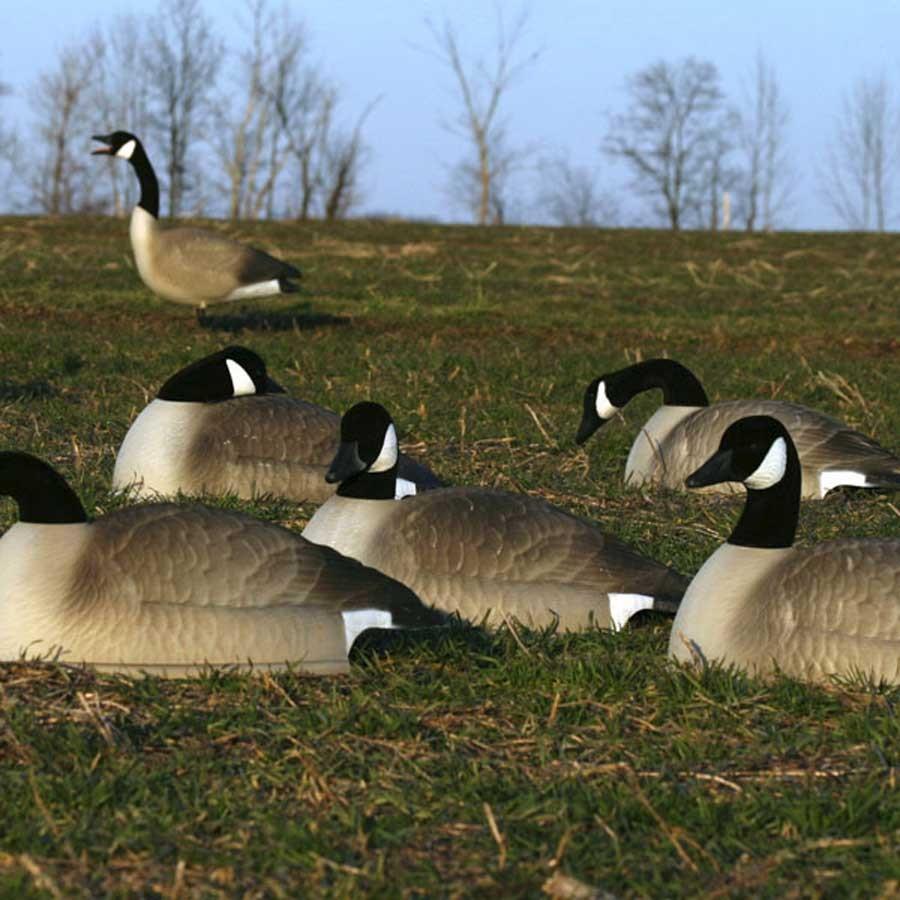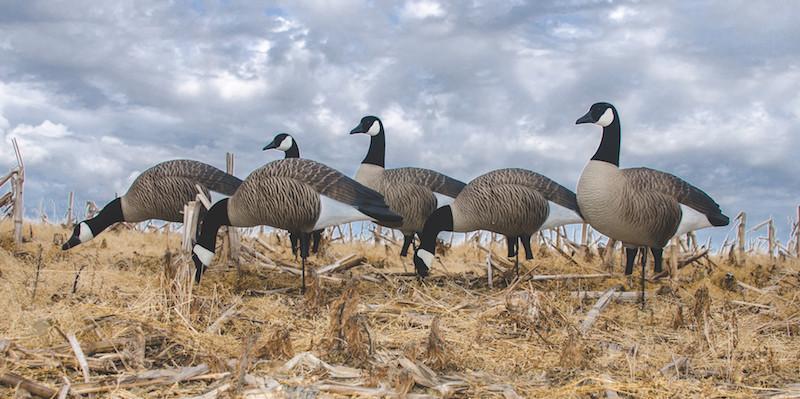The first image is the image on the left, the second image is the image on the right. Examine the images to the left and right. Is the description "At least one person is walking with the birds in one of the images." accurate? Answer yes or no. No. The first image is the image on the left, the second image is the image on the right. For the images displayed, is the sentence "Each image shows a flock of canada geese with no fewer than 6 birds" factually correct? Answer yes or no. Yes. The first image is the image on the left, the second image is the image on the right. Assess this claim about the two images: "An image shows a girl in a head covering standing behind a flock of white birds and holding a stick.". Correct or not? Answer yes or no. No. The first image is the image on the left, the second image is the image on the right. Evaluate the accuracy of this statement regarding the images: "There are at least two ducks standing next to each other with orange beaks.". Is it true? Answer yes or no. No. 